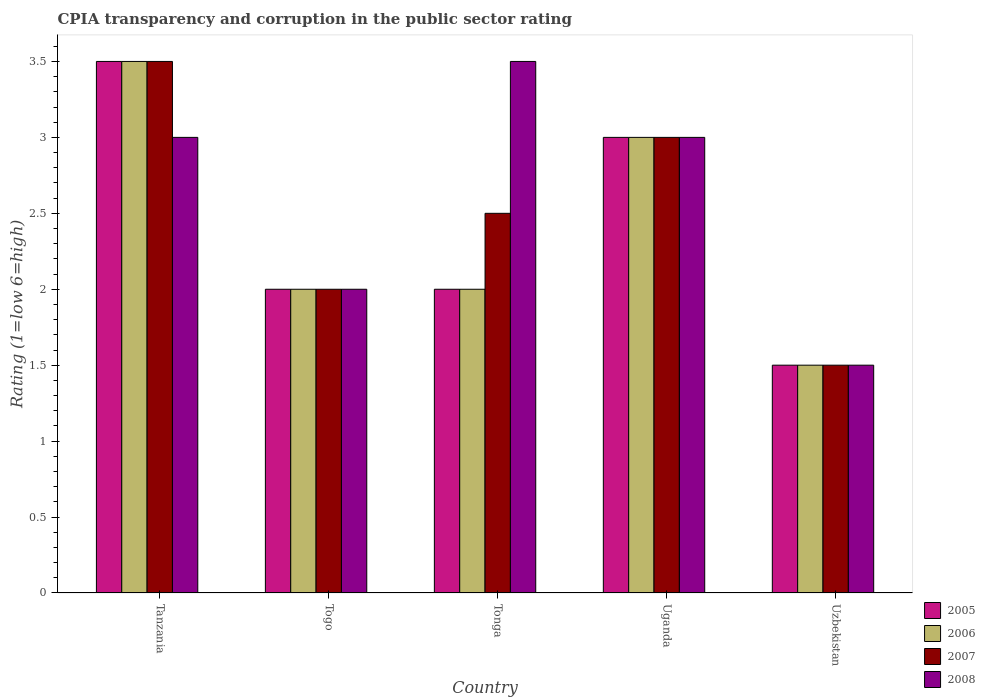Are the number of bars on each tick of the X-axis equal?
Offer a very short reply. Yes. What is the label of the 2nd group of bars from the left?
Your answer should be compact. Togo. In which country was the CPIA rating in 2005 maximum?
Your response must be concise. Tanzania. In which country was the CPIA rating in 2005 minimum?
Keep it short and to the point. Uzbekistan. What is the difference between the CPIA rating in 2005 in Uzbekistan and the CPIA rating in 2006 in Togo?
Offer a terse response. -0.5. What is the average CPIA rating in 2005 per country?
Offer a very short reply. 2.4. What is the ratio of the CPIA rating in 2006 in Togo to that in Uzbekistan?
Make the answer very short. 1.33. Is the CPIA rating in 2005 in Tanzania less than that in Uganda?
Offer a very short reply. No. Is the difference between the CPIA rating in 2007 in Togo and Uzbekistan greater than the difference between the CPIA rating in 2008 in Togo and Uzbekistan?
Your response must be concise. No. What is the difference between the highest and the second highest CPIA rating in 2006?
Provide a succinct answer. 1. Is it the case that in every country, the sum of the CPIA rating in 2007 and CPIA rating in 2005 is greater than the sum of CPIA rating in 2008 and CPIA rating in 2006?
Your answer should be compact. No. Is it the case that in every country, the sum of the CPIA rating in 2007 and CPIA rating in 2005 is greater than the CPIA rating in 2008?
Provide a short and direct response. Yes. How many bars are there?
Ensure brevity in your answer.  20. Are the values on the major ticks of Y-axis written in scientific E-notation?
Keep it short and to the point. No. Does the graph contain any zero values?
Your answer should be very brief. No. Does the graph contain grids?
Your response must be concise. No. Where does the legend appear in the graph?
Offer a terse response. Bottom right. How many legend labels are there?
Your response must be concise. 4. What is the title of the graph?
Give a very brief answer. CPIA transparency and corruption in the public sector rating. What is the label or title of the Y-axis?
Provide a succinct answer. Rating (1=low 6=high). What is the Rating (1=low 6=high) of 2008 in Tanzania?
Your response must be concise. 3. What is the Rating (1=low 6=high) of 2005 in Tonga?
Give a very brief answer. 2. What is the Rating (1=low 6=high) of 2006 in Tonga?
Your response must be concise. 2. What is the Rating (1=low 6=high) in 2006 in Uganda?
Your response must be concise. 3. What is the Rating (1=low 6=high) of 2008 in Uganda?
Provide a short and direct response. 3. What is the Rating (1=low 6=high) of 2005 in Uzbekistan?
Offer a terse response. 1.5. What is the Rating (1=low 6=high) of 2006 in Uzbekistan?
Offer a terse response. 1.5. What is the Rating (1=low 6=high) of 2007 in Uzbekistan?
Your response must be concise. 1.5. What is the Rating (1=low 6=high) of 2008 in Uzbekistan?
Your answer should be very brief. 1.5. Across all countries, what is the maximum Rating (1=low 6=high) in 2006?
Offer a very short reply. 3.5. Across all countries, what is the minimum Rating (1=low 6=high) of 2006?
Give a very brief answer. 1.5. Across all countries, what is the minimum Rating (1=low 6=high) in 2008?
Your answer should be very brief. 1.5. What is the total Rating (1=low 6=high) in 2006 in the graph?
Keep it short and to the point. 12. What is the difference between the Rating (1=low 6=high) of 2005 in Tanzania and that in Togo?
Ensure brevity in your answer.  1.5. What is the difference between the Rating (1=low 6=high) in 2007 in Tanzania and that in Togo?
Give a very brief answer. 1.5. What is the difference between the Rating (1=low 6=high) of 2008 in Tanzania and that in Togo?
Keep it short and to the point. 1. What is the difference between the Rating (1=low 6=high) of 2005 in Tanzania and that in Tonga?
Provide a succinct answer. 1.5. What is the difference between the Rating (1=low 6=high) of 2008 in Tanzania and that in Tonga?
Offer a terse response. -0.5. What is the difference between the Rating (1=low 6=high) in 2005 in Tanzania and that in Uganda?
Give a very brief answer. 0.5. What is the difference between the Rating (1=low 6=high) of 2006 in Tanzania and that in Uganda?
Keep it short and to the point. 0.5. What is the difference between the Rating (1=low 6=high) in 2008 in Tanzania and that in Uganda?
Your response must be concise. 0. What is the difference between the Rating (1=low 6=high) in 2005 in Tanzania and that in Uzbekistan?
Your answer should be compact. 2. What is the difference between the Rating (1=low 6=high) of 2007 in Tanzania and that in Uzbekistan?
Provide a short and direct response. 2. What is the difference between the Rating (1=low 6=high) of 2007 in Togo and that in Tonga?
Your answer should be very brief. -0.5. What is the difference between the Rating (1=low 6=high) in 2006 in Togo and that in Uganda?
Provide a succinct answer. -1. What is the difference between the Rating (1=low 6=high) in 2007 in Togo and that in Uganda?
Provide a succinct answer. -1. What is the difference between the Rating (1=low 6=high) of 2005 in Togo and that in Uzbekistan?
Offer a very short reply. 0.5. What is the difference between the Rating (1=low 6=high) in 2006 in Togo and that in Uzbekistan?
Provide a succinct answer. 0.5. What is the difference between the Rating (1=low 6=high) in 2007 in Togo and that in Uzbekistan?
Provide a succinct answer. 0.5. What is the difference between the Rating (1=low 6=high) in 2008 in Togo and that in Uzbekistan?
Keep it short and to the point. 0.5. What is the difference between the Rating (1=low 6=high) in 2007 in Tonga and that in Uganda?
Your answer should be very brief. -0.5. What is the difference between the Rating (1=low 6=high) in 2008 in Tonga and that in Uzbekistan?
Provide a short and direct response. 2. What is the difference between the Rating (1=low 6=high) of 2005 in Tanzania and the Rating (1=low 6=high) of 2007 in Togo?
Your answer should be very brief. 1.5. What is the difference between the Rating (1=low 6=high) of 2005 in Tanzania and the Rating (1=low 6=high) of 2008 in Togo?
Your response must be concise. 1.5. What is the difference between the Rating (1=low 6=high) in 2007 in Tanzania and the Rating (1=low 6=high) in 2008 in Togo?
Provide a short and direct response. 1.5. What is the difference between the Rating (1=low 6=high) in 2005 in Tanzania and the Rating (1=low 6=high) in 2006 in Tonga?
Your response must be concise. 1.5. What is the difference between the Rating (1=low 6=high) of 2006 in Tanzania and the Rating (1=low 6=high) of 2007 in Tonga?
Your answer should be compact. 1. What is the difference between the Rating (1=low 6=high) in 2007 in Tanzania and the Rating (1=low 6=high) in 2008 in Tonga?
Your answer should be very brief. 0. What is the difference between the Rating (1=low 6=high) in 2005 in Tanzania and the Rating (1=low 6=high) in 2007 in Uzbekistan?
Provide a succinct answer. 2. What is the difference between the Rating (1=low 6=high) in 2005 in Tanzania and the Rating (1=low 6=high) in 2008 in Uzbekistan?
Offer a very short reply. 2. What is the difference between the Rating (1=low 6=high) of 2006 in Tanzania and the Rating (1=low 6=high) of 2008 in Uzbekistan?
Provide a short and direct response. 2. What is the difference between the Rating (1=low 6=high) of 2005 in Togo and the Rating (1=low 6=high) of 2007 in Tonga?
Offer a very short reply. -0.5. What is the difference between the Rating (1=low 6=high) in 2006 in Togo and the Rating (1=low 6=high) in 2007 in Tonga?
Provide a succinct answer. -0.5. What is the difference between the Rating (1=low 6=high) in 2007 in Togo and the Rating (1=low 6=high) in 2008 in Tonga?
Your response must be concise. -1.5. What is the difference between the Rating (1=low 6=high) in 2005 in Togo and the Rating (1=low 6=high) in 2007 in Uganda?
Make the answer very short. -1. What is the difference between the Rating (1=low 6=high) of 2006 in Togo and the Rating (1=low 6=high) of 2007 in Uganda?
Offer a terse response. -1. What is the difference between the Rating (1=low 6=high) of 2006 in Togo and the Rating (1=low 6=high) of 2008 in Uganda?
Keep it short and to the point. -1. What is the difference between the Rating (1=low 6=high) in 2007 in Togo and the Rating (1=low 6=high) in 2008 in Uganda?
Your answer should be very brief. -1. What is the difference between the Rating (1=low 6=high) in 2005 in Togo and the Rating (1=low 6=high) in 2008 in Uzbekistan?
Provide a succinct answer. 0.5. What is the difference between the Rating (1=low 6=high) in 2006 in Togo and the Rating (1=low 6=high) in 2007 in Uzbekistan?
Your answer should be compact. 0.5. What is the difference between the Rating (1=low 6=high) in 2007 in Togo and the Rating (1=low 6=high) in 2008 in Uzbekistan?
Your answer should be very brief. 0.5. What is the difference between the Rating (1=low 6=high) of 2005 in Tonga and the Rating (1=low 6=high) of 2006 in Uganda?
Keep it short and to the point. -1. What is the difference between the Rating (1=low 6=high) of 2005 in Tonga and the Rating (1=low 6=high) of 2007 in Uganda?
Ensure brevity in your answer.  -1. What is the difference between the Rating (1=low 6=high) of 2005 in Tonga and the Rating (1=low 6=high) of 2008 in Uganda?
Offer a very short reply. -1. What is the difference between the Rating (1=low 6=high) in 2006 in Tonga and the Rating (1=low 6=high) in 2007 in Uganda?
Give a very brief answer. -1. What is the difference between the Rating (1=low 6=high) in 2006 in Tonga and the Rating (1=low 6=high) in 2008 in Uganda?
Offer a terse response. -1. What is the difference between the Rating (1=low 6=high) of 2005 in Tonga and the Rating (1=low 6=high) of 2008 in Uzbekistan?
Make the answer very short. 0.5. What is the difference between the Rating (1=low 6=high) in 2006 in Tonga and the Rating (1=low 6=high) in 2007 in Uzbekistan?
Your response must be concise. 0.5. What is the difference between the Rating (1=low 6=high) in 2005 in Uganda and the Rating (1=low 6=high) in 2006 in Uzbekistan?
Make the answer very short. 1.5. What is the difference between the Rating (1=low 6=high) in 2005 in Uganda and the Rating (1=low 6=high) in 2007 in Uzbekistan?
Your answer should be compact. 1.5. What is the difference between the Rating (1=low 6=high) of 2005 in Uganda and the Rating (1=low 6=high) of 2008 in Uzbekistan?
Offer a terse response. 1.5. What is the difference between the Rating (1=low 6=high) in 2006 in Uganda and the Rating (1=low 6=high) in 2007 in Uzbekistan?
Offer a very short reply. 1.5. What is the difference between the Rating (1=low 6=high) of 2006 in Uganda and the Rating (1=low 6=high) of 2008 in Uzbekistan?
Provide a short and direct response. 1.5. What is the difference between the Rating (1=low 6=high) in 2007 in Uganda and the Rating (1=low 6=high) in 2008 in Uzbekistan?
Keep it short and to the point. 1.5. What is the average Rating (1=low 6=high) of 2006 per country?
Ensure brevity in your answer.  2.4. What is the average Rating (1=low 6=high) of 2008 per country?
Your answer should be compact. 2.6. What is the difference between the Rating (1=low 6=high) of 2005 and Rating (1=low 6=high) of 2007 in Tanzania?
Ensure brevity in your answer.  0. What is the difference between the Rating (1=low 6=high) of 2005 and Rating (1=low 6=high) of 2008 in Tanzania?
Your answer should be compact. 0.5. What is the difference between the Rating (1=low 6=high) of 2005 and Rating (1=low 6=high) of 2006 in Togo?
Keep it short and to the point. 0. What is the difference between the Rating (1=low 6=high) of 2005 and Rating (1=low 6=high) of 2007 in Togo?
Offer a very short reply. 0. What is the difference between the Rating (1=low 6=high) in 2005 and Rating (1=low 6=high) in 2008 in Togo?
Provide a succinct answer. 0. What is the difference between the Rating (1=low 6=high) in 2007 and Rating (1=low 6=high) in 2008 in Togo?
Ensure brevity in your answer.  0. What is the difference between the Rating (1=low 6=high) of 2005 and Rating (1=low 6=high) of 2007 in Tonga?
Ensure brevity in your answer.  -0.5. What is the difference between the Rating (1=low 6=high) in 2005 and Rating (1=low 6=high) in 2008 in Tonga?
Keep it short and to the point. -1.5. What is the difference between the Rating (1=low 6=high) in 2005 and Rating (1=low 6=high) in 2006 in Uganda?
Give a very brief answer. 0. What is the difference between the Rating (1=low 6=high) in 2005 and Rating (1=low 6=high) in 2008 in Uganda?
Your response must be concise. 0. What is the difference between the Rating (1=low 6=high) in 2005 and Rating (1=low 6=high) in 2006 in Uzbekistan?
Give a very brief answer. 0. What is the difference between the Rating (1=low 6=high) of 2005 and Rating (1=low 6=high) of 2007 in Uzbekistan?
Your response must be concise. 0. What is the difference between the Rating (1=low 6=high) in 2005 and Rating (1=low 6=high) in 2008 in Uzbekistan?
Give a very brief answer. 0. What is the difference between the Rating (1=low 6=high) of 2006 and Rating (1=low 6=high) of 2007 in Uzbekistan?
Provide a succinct answer. 0. What is the difference between the Rating (1=low 6=high) in 2006 and Rating (1=low 6=high) in 2008 in Uzbekistan?
Your answer should be very brief. 0. What is the difference between the Rating (1=low 6=high) of 2007 and Rating (1=low 6=high) of 2008 in Uzbekistan?
Give a very brief answer. 0. What is the ratio of the Rating (1=low 6=high) in 2006 in Tanzania to that in Togo?
Give a very brief answer. 1.75. What is the ratio of the Rating (1=low 6=high) in 2007 in Tanzania to that in Togo?
Make the answer very short. 1.75. What is the ratio of the Rating (1=low 6=high) in 2008 in Tanzania to that in Togo?
Your response must be concise. 1.5. What is the ratio of the Rating (1=low 6=high) in 2005 in Tanzania to that in Tonga?
Ensure brevity in your answer.  1.75. What is the ratio of the Rating (1=low 6=high) in 2006 in Tanzania to that in Tonga?
Provide a succinct answer. 1.75. What is the ratio of the Rating (1=low 6=high) of 2007 in Tanzania to that in Tonga?
Your response must be concise. 1.4. What is the ratio of the Rating (1=low 6=high) in 2008 in Tanzania to that in Tonga?
Offer a very short reply. 0.86. What is the ratio of the Rating (1=low 6=high) of 2006 in Tanzania to that in Uganda?
Give a very brief answer. 1.17. What is the ratio of the Rating (1=low 6=high) in 2007 in Tanzania to that in Uganda?
Your answer should be compact. 1.17. What is the ratio of the Rating (1=low 6=high) of 2005 in Tanzania to that in Uzbekistan?
Your answer should be compact. 2.33. What is the ratio of the Rating (1=low 6=high) in 2006 in Tanzania to that in Uzbekistan?
Your answer should be very brief. 2.33. What is the ratio of the Rating (1=low 6=high) of 2007 in Tanzania to that in Uzbekistan?
Ensure brevity in your answer.  2.33. What is the ratio of the Rating (1=low 6=high) in 2008 in Tanzania to that in Uzbekistan?
Offer a very short reply. 2. What is the ratio of the Rating (1=low 6=high) of 2007 in Togo to that in Tonga?
Your response must be concise. 0.8. What is the ratio of the Rating (1=low 6=high) in 2006 in Togo to that in Uganda?
Your answer should be very brief. 0.67. What is the ratio of the Rating (1=low 6=high) of 2005 in Togo to that in Uzbekistan?
Ensure brevity in your answer.  1.33. What is the ratio of the Rating (1=low 6=high) of 2008 in Togo to that in Uzbekistan?
Your answer should be very brief. 1.33. What is the ratio of the Rating (1=low 6=high) of 2006 in Tonga to that in Uganda?
Offer a terse response. 0.67. What is the ratio of the Rating (1=low 6=high) of 2007 in Tonga to that in Uganda?
Keep it short and to the point. 0.83. What is the ratio of the Rating (1=low 6=high) of 2008 in Tonga to that in Uganda?
Your answer should be compact. 1.17. What is the ratio of the Rating (1=low 6=high) in 2006 in Tonga to that in Uzbekistan?
Offer a terse response. 1.33. What is the ratio of the Rating (1=low 6=high) in 2008 in Tonga to that in Uzbekistan?
Make the answer very short. 2.33. What is the ratio of the Rating (1=low 6=high) of 2007 in Uganda to that in Uzbekistan?
Give a very brief answer. 2. What is the difference between the highest and the second highest Rating (1=low 6=high) of 2008?
Your response must be concise. 0.5. What is the difference between the highest and the lowest Rating (1=low 6=high) of 2008?
Provide a succinct answer. 2. 